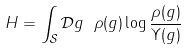<formula> <loc_0><loc_0><loc_500><loc_500>H = \int _ { \mathcal { S } } \mathcal { D } g \ \rho ( g ) \log \frac { \rho ( g ) } { \Upsilon ( g ) }</formula> 